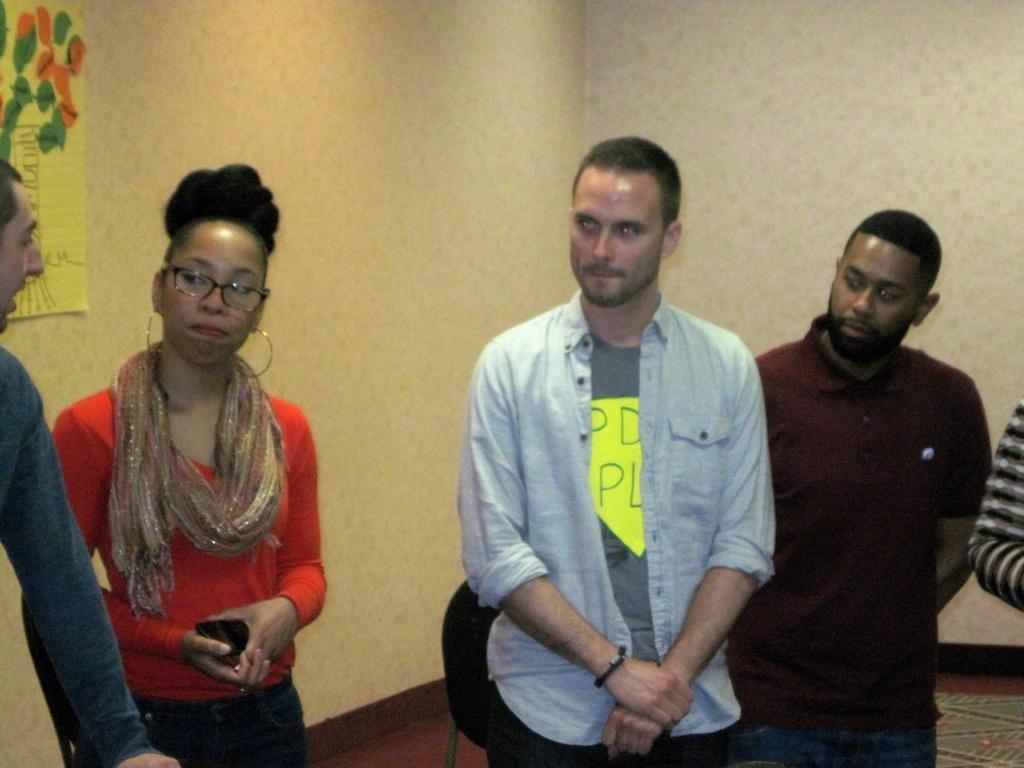Please provide a concise description of this image. In this picture I can see few people are standing and I can see a poster on the wall and looks like a chair in the back and I can see wall in the background and a woman holding a mobile in her hand. 